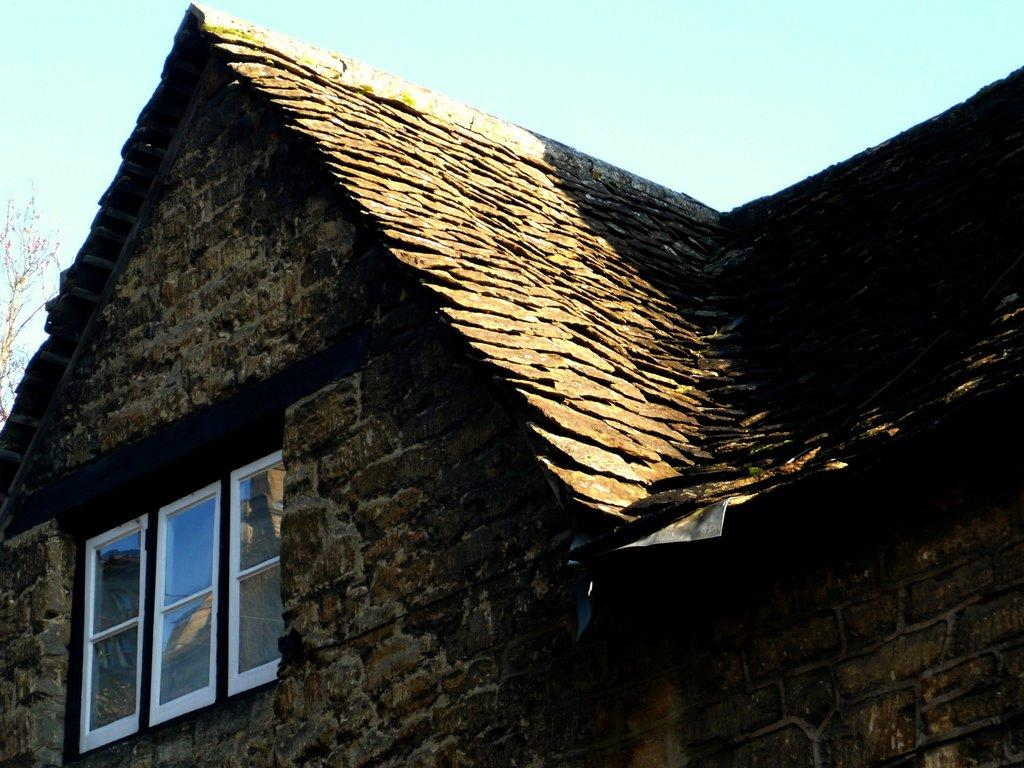What is the main subject of the picture? The main subject of the picture is a house. What specific features can be seen on the house? The house has windows. What can be seen in the background of the picture? There is a tree and the sky visible in the background of the picture. What type of verse is written on the tree in the image? There is no verse written on the tree in the image. The image only shows a house with windows, a tree, and the sky in the background. There is no verse or writing present on the tree in the image. 